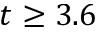<formula> <loc_0><loc_0><loc_500><loc_500>t \geq 3 . 6</formula> 